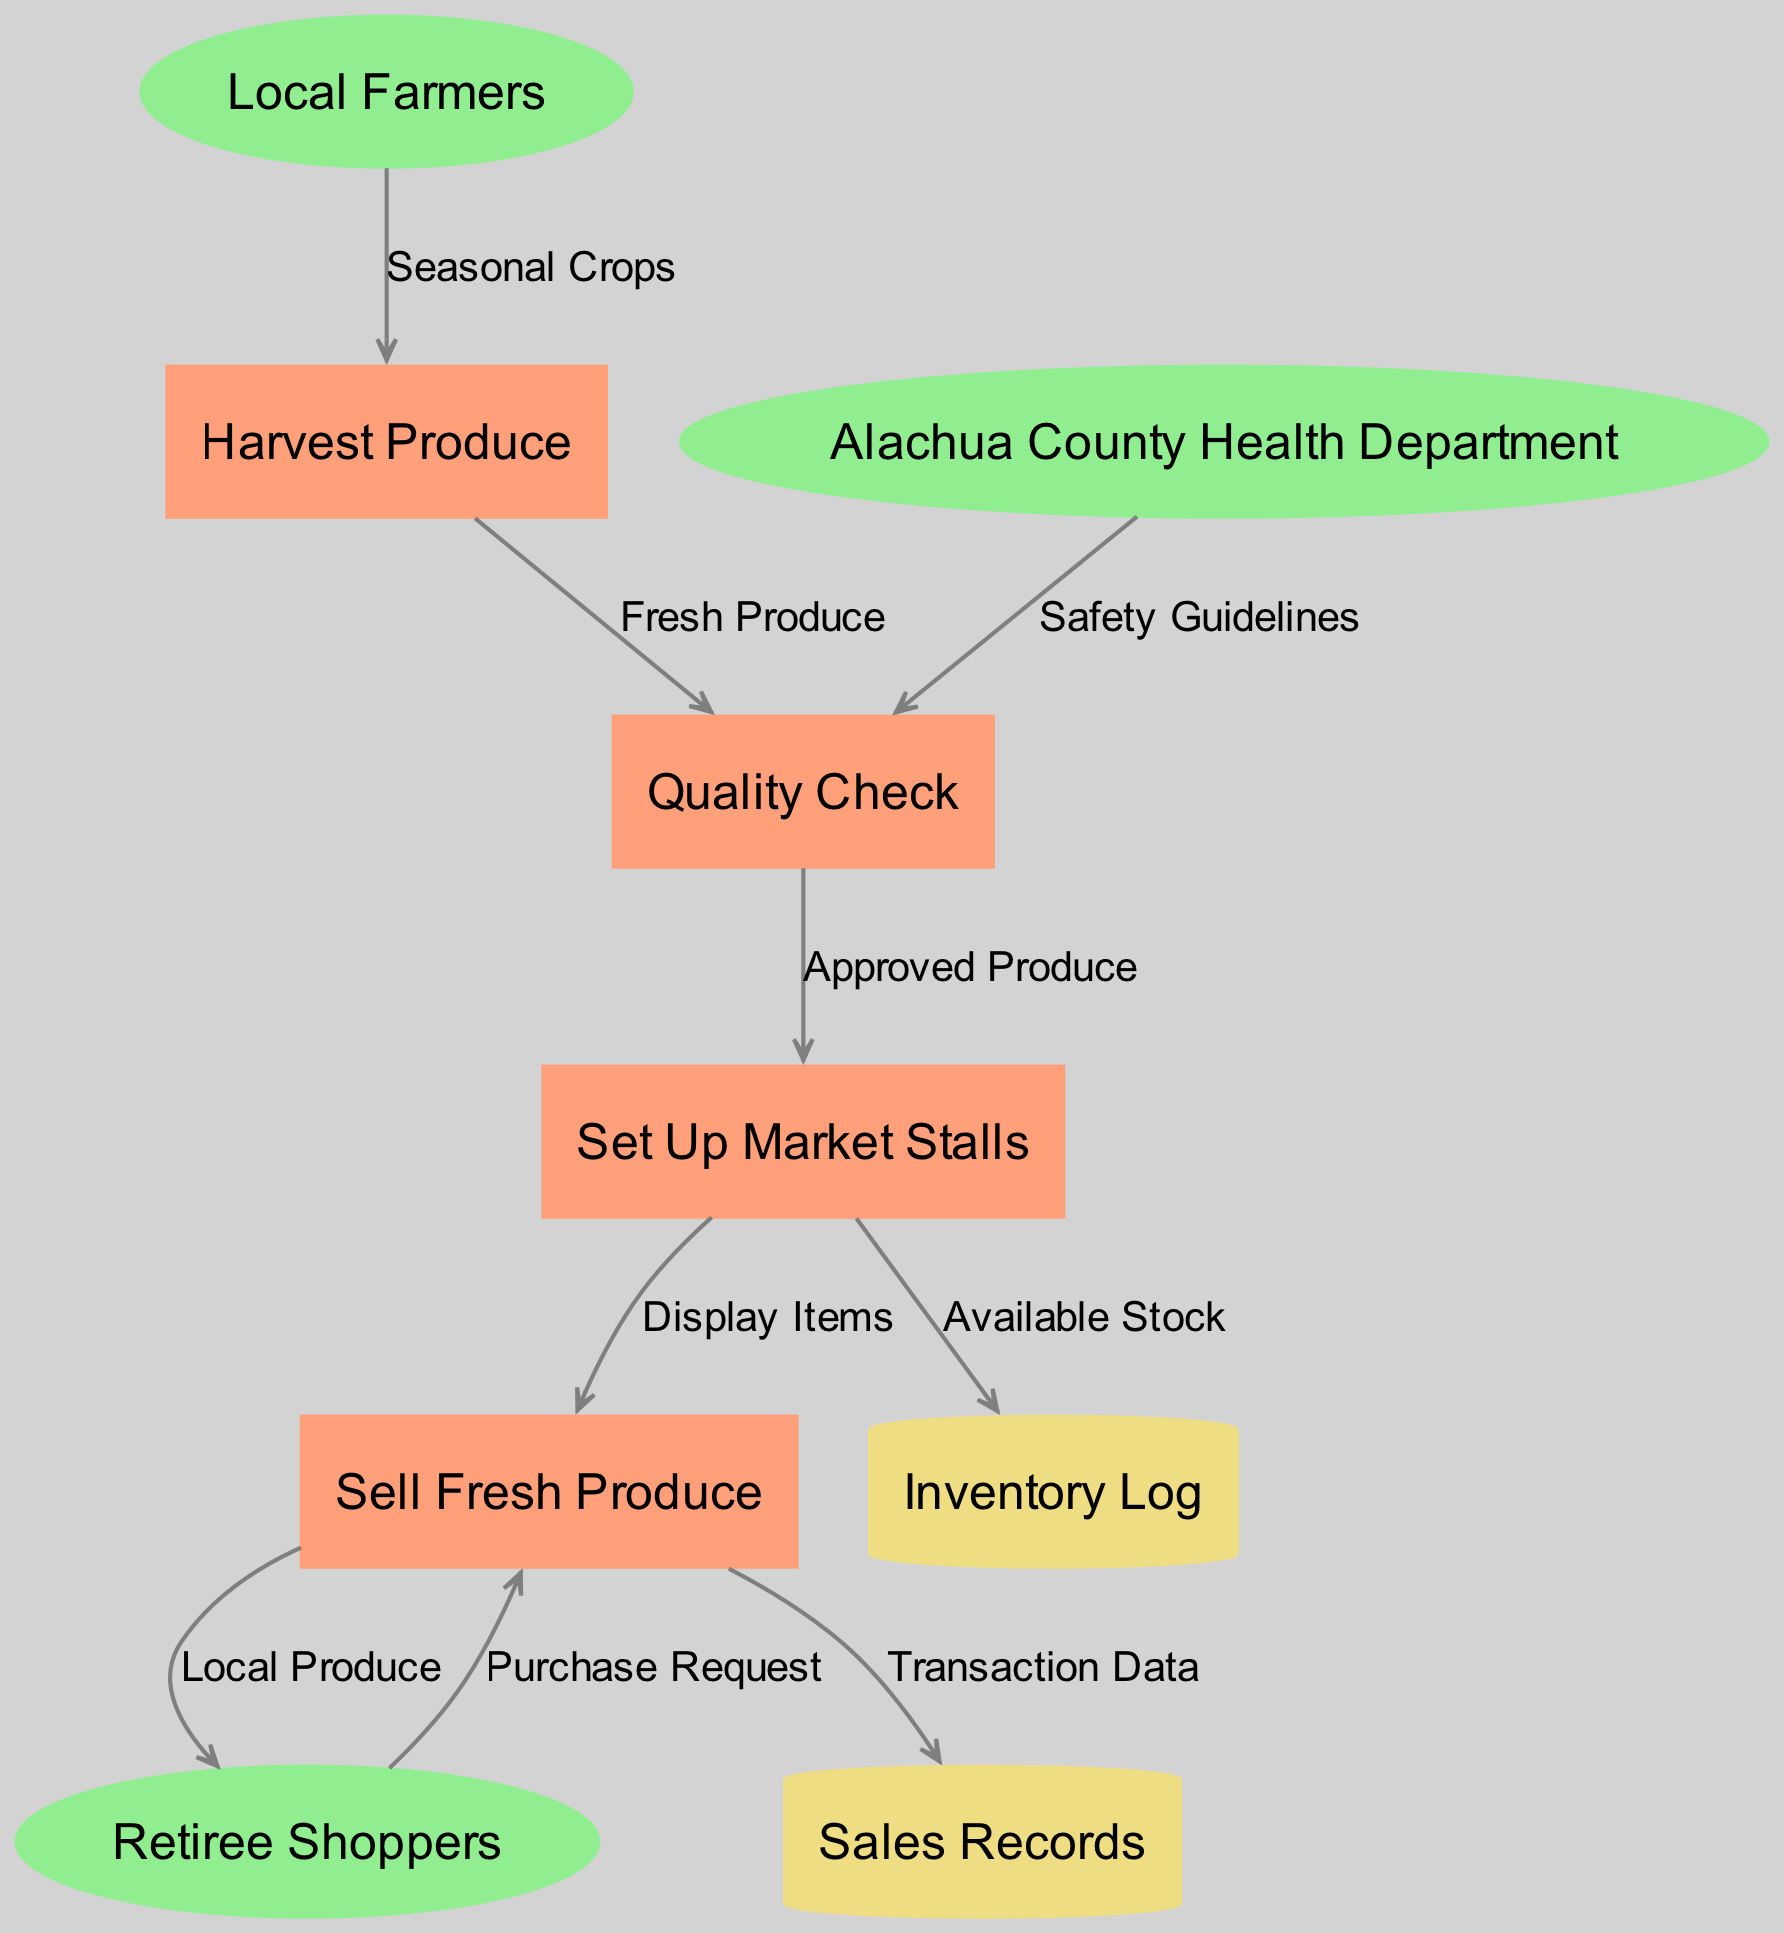What are the external entities represented in the diagram? The external entities are indicated at the start of the diagram and include "Local Farmers", "Retiree Shoppers", and "Alachua County Health Department".
Answer: Local Farmers, Retiree Shoppers, Alachua County Health Department How many processes are there in the diagram? By counting the nodes labeled as processes in the diagram, we find there are four processes: "Harvest Produce", "Quality Check", "Set Up Market Stalls", and "Sell Fresh Produce".
Answer: 4 Which process comes after "Harvest Produce"? The data flow indicates that after the "Harvest Produce" process, the next step is "Quality Check". This is shown by the flow from "Harvest Produce" to "Quality Check" labeled with "Fresh Produce".
Answer: Quality Check What is the label of the flow from "Set Up Market Stalls" to "Sell Fresh Produce"? The diagram shows a flow from "Set Up Market Stalls" to "Sell Fresh Produce" with the label "Display Items".
Answer: Display Items Which external entity provides "Safety Guidelines"? The diagram indicates that "Alachua County Health Department" is the external entity that provides "Safety Guidelines" to the "Quality Check" process.
Answer: Alachua County Health Department What data store receives data from "Sell Fresh Produce"? According to the diagram, "Sales Records" receive data from the "Sell Fresh Produce" process under the label "Transaction Data".
Answer: Sales Records Which process receives the "Purchase Request"? The "Sell Fresh Produce" process receives the "Purchase Request" from "Retiree Shoppers", as shown by the data flow heading in that direction.
Answer: Sell Fresh Produce What kind of data is stored in the "Inventory Log"? The flow from "Set Up Market Stalls" to "Inventory Log" is labeled "Available Stock", indicating that this log contains details about the current available stock of produce.
Answer: Available Stock 